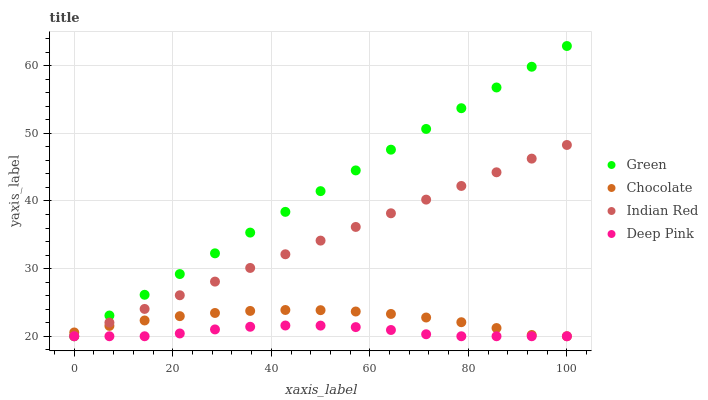Does Deep Pink have the minimum area under the curve?
Answer yes or no. Yes. Does Green have the maximum area under the curve?
Answer yes or no. Yes. Does Indian Red have the minimum area under the curve?
Answer yes or no. No. Does Indian Red have the maximum area under the curve?
Answer yes or no. No. Is Indian Red the smoothest?
Answer yes or no. Yes. Is Chocolate the roughest?
Answer yes or no. Yes. Is Green the smoothest?
Answer yes or no. No. Is Green the roughest?
Answer yes or no. No. Does Deep Pink have the lowest value?
Answer yes or no. Yes. Does Green have the highest value?
Answer yes or no. Yes. Does Indian Red have the highest value?
Answer yes or no. No. Does Indian Red intersect Chocolate?
Answer yes or no. Yes. Is Indian Red less than Chocolate?
Answer yes or no. No. Is Indian Red greater than Chocolate?
Answer yes or no. No. 